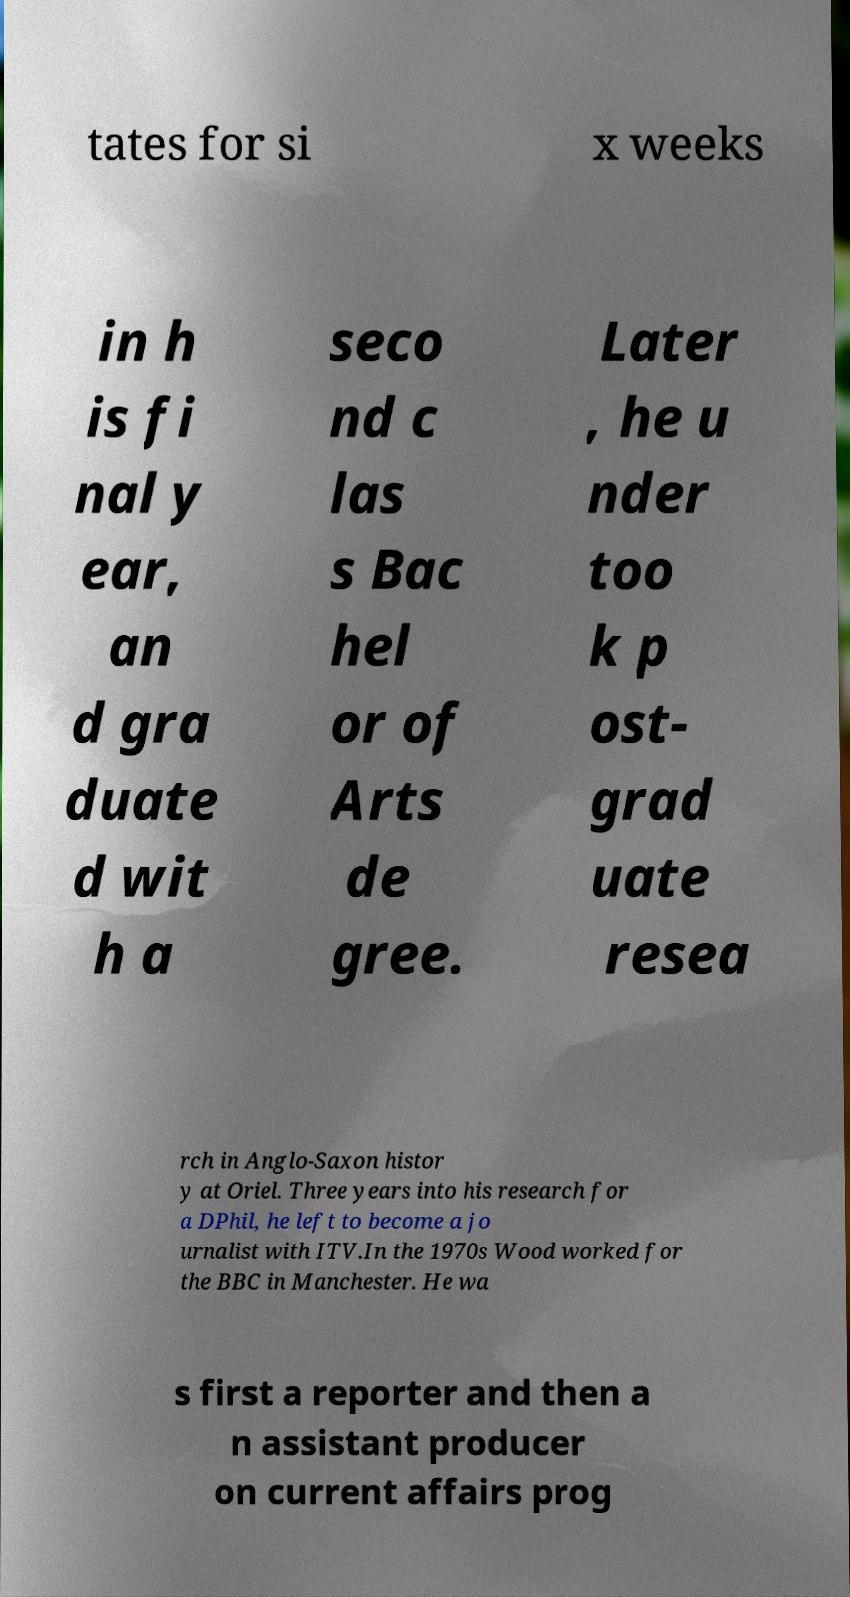Could you extract and type out the text from this image? tates for si x weeks in h is fi nal y ear, an d gra duate d wit h a seco nd c las s Bac hel or of Arts de gree. Later , he u nder too k p ost- grad uate resea rch in Anglo-Saxon histor y at Oriel. Three years into his research for a DPhil, he left to become a jo urnalist with ITV.In the 1970s Wood worked for the BBC in Manchester. He wa s first a reporter and then a n assistant producer on current affairs prog 